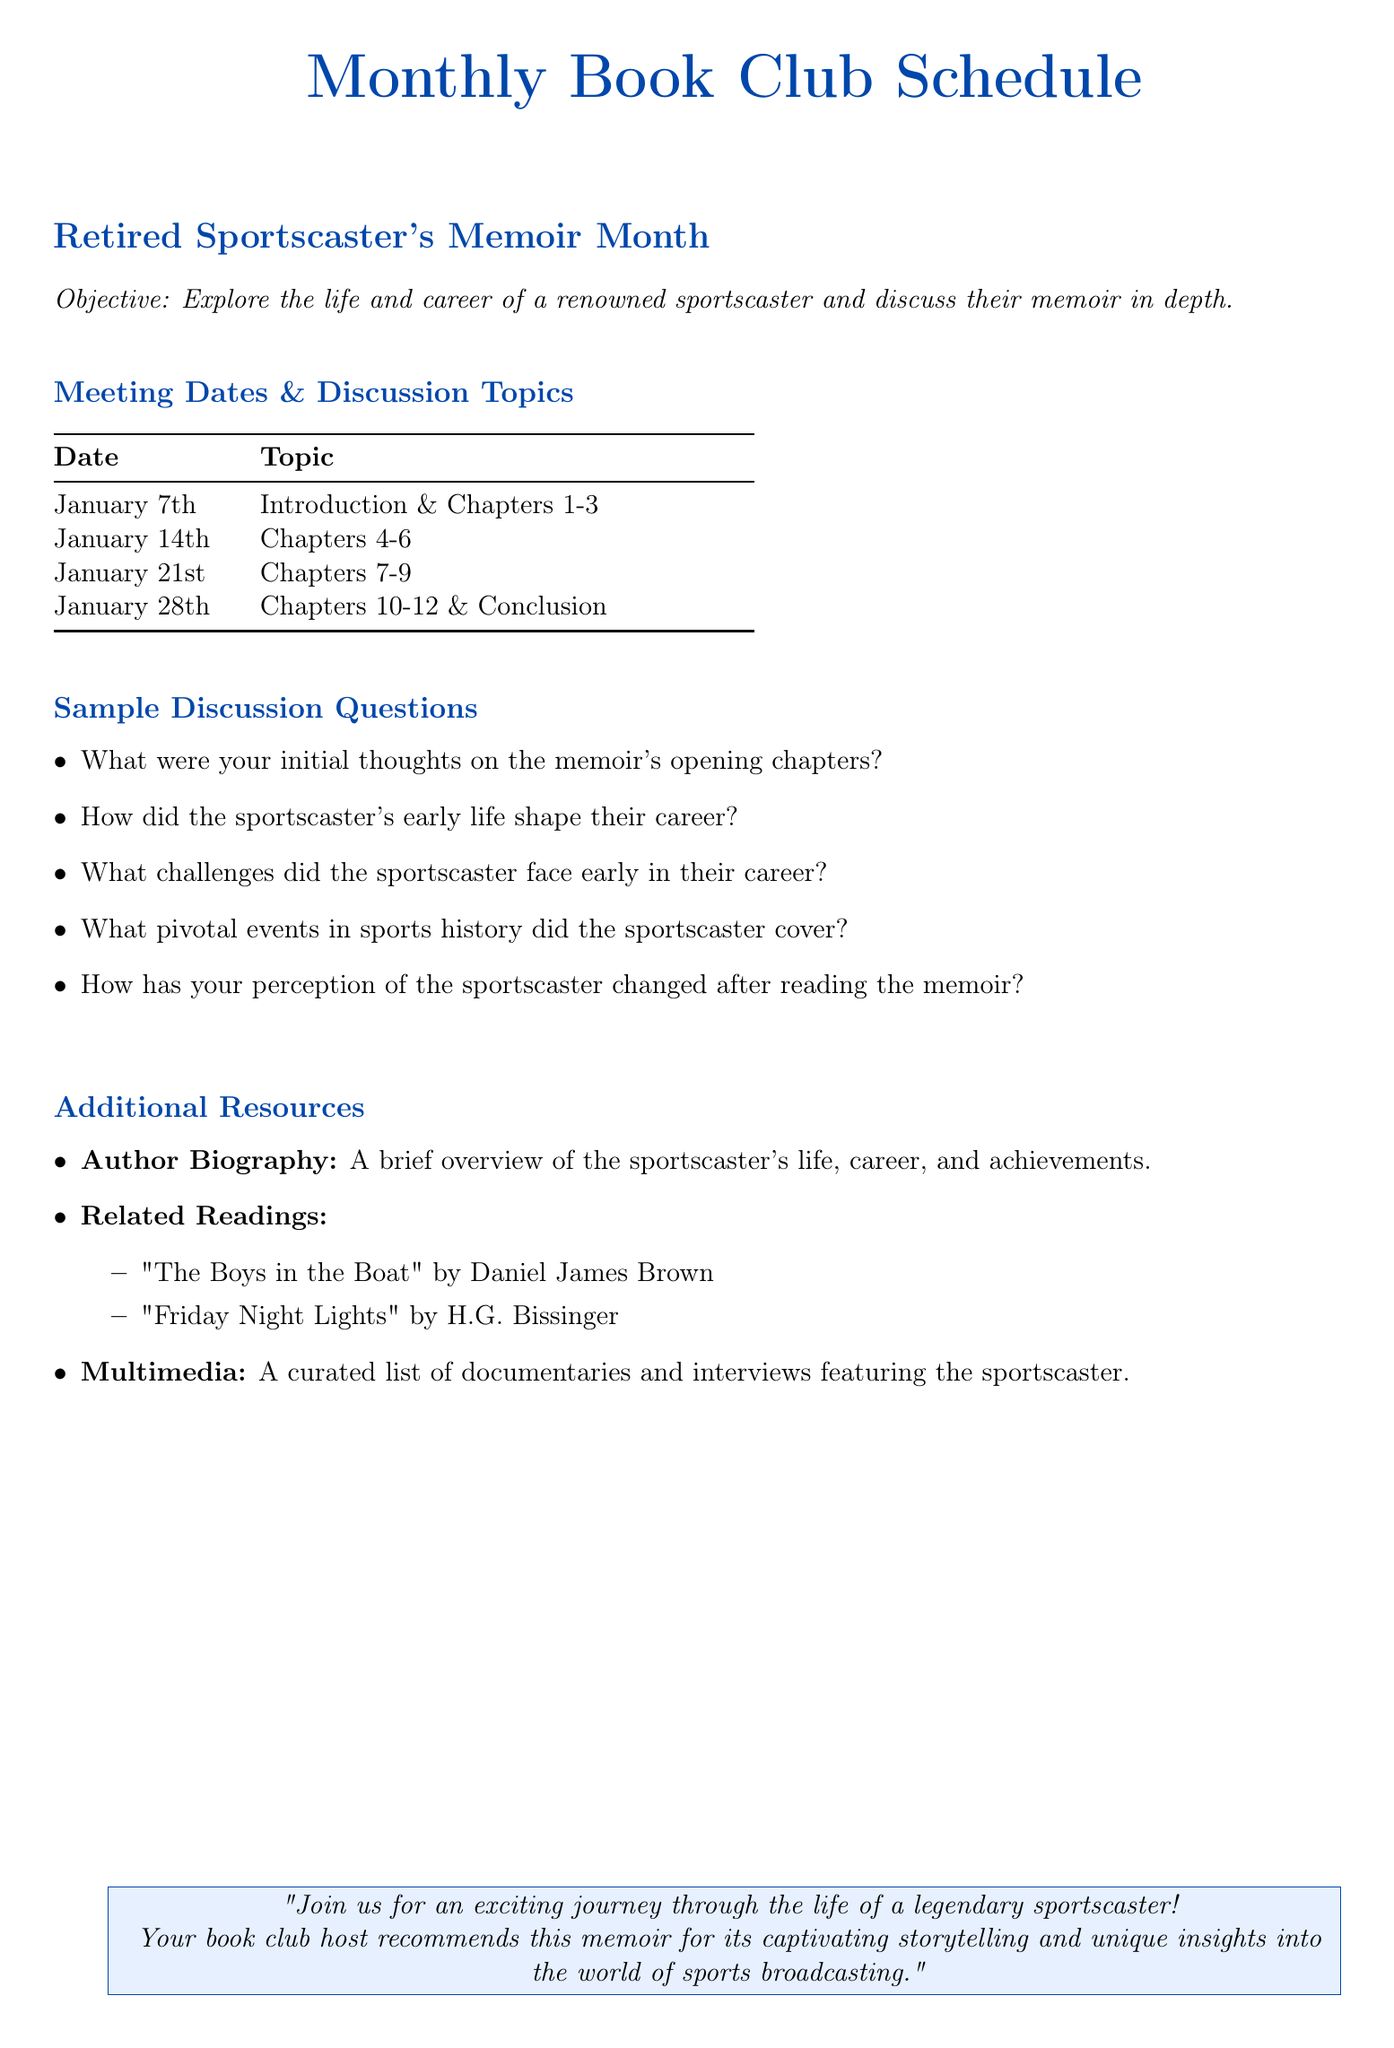What is the memoir's focus? The document states that the objective is to explore the life and career of a renowned sportscaster, which indicates the memoir's focus.
Answer: Life and career of a sportscaster How many chapters are covered in the first meeting? The first meeting discusses the introduction and chapters 1-3, indicating a total of three chapters are covered.
Answer: 3 What is the date of the final discussion meeting? The last meeting is scheduled for January 28th, as indicated in the table for meeting dates and topics.
Answer: January 28th List one recommended related reading. The document provides a list of related readings; one of these titles can be used as an answer.
Answer: The Boys in the Boat What is one of the sample discussion questions? The document includes several sample discussion questions, any of which can serve as an answer.
Answer: How did the sportscaster's early life shape their career? What is the color of the book club heading? The document specifies that the heading is colored book blue, which describes its appearance.
Answer: Book blue What are the two topics covered in the meeting on January 28th? The document specifies that the meeting on January 28th will cover chapters 10-12 and the conclusion, combining both topics.
Answer: Chapters 10-12 & Conclusion 